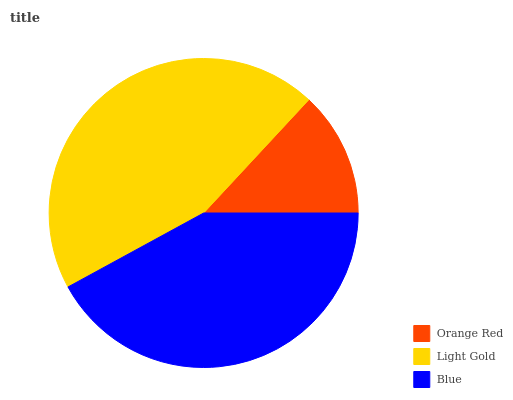Is Orange Red the minimum?
Answer yes or no. Yes. Is Light Gold the maximum?
Answer yes or no. Yes. Is Blue the minimum?
Answer yes or no. No. Is Blue the maximum?
Answer yes or no. No. Is Light Gold greater than Blue?
Answer yes or no. Yes. Is Blue less than Light Gold?
Answer yes or no. Yes. Is Blue greater than Light Gold?
Answer yes or no. No. Is Light Gold less than Blue?
Answer yes or no. No. Is Blue the high median?
Answer yes or no. Yes. Is Blue the low median?
Answer yes or no. Yes. Is Orange Red the high median?
Answer yes or no. No. Is Light Gold the low median?
Answer yes or no. No. 